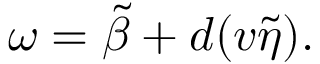<formula> <loc_0><loc_0><loc_500><loc_500>\omega = \tilde { \beta } + d ( v \tilde { \eta } ) .</formula> 